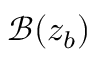<formula> <loc_0><loc_0><loc_500><loc_500>\mathcal { B } ( z _ { b } )</formula> 